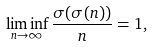Convert formula to latex. <formula><loc_0><loc_0><loc_500><loc_500>\liminf _ { n \to \infty } \frac { \sigma ( \sigma ( n ) ) } { n } = 1 ,</formula> 